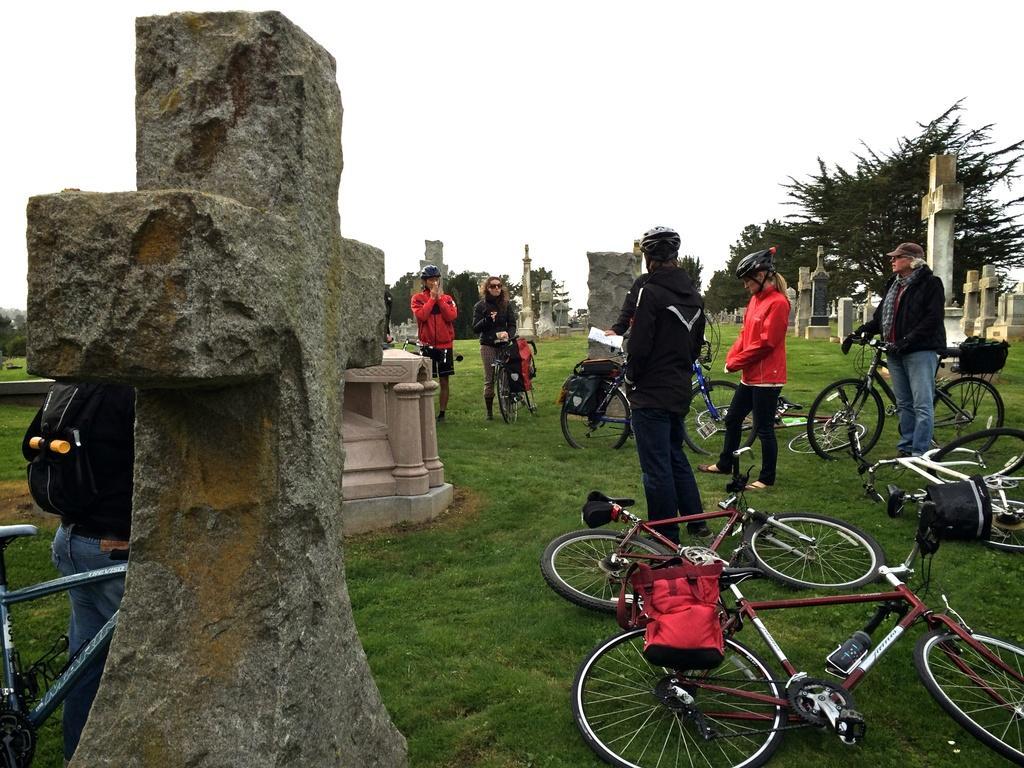Please provide a concise description of this image. In this image there are many people. Some are wearing helmets and caps. On the ground there is grass. Also there are cycles. On the left side there is a stone cross. In the background there are many crosses, trees and sky. 